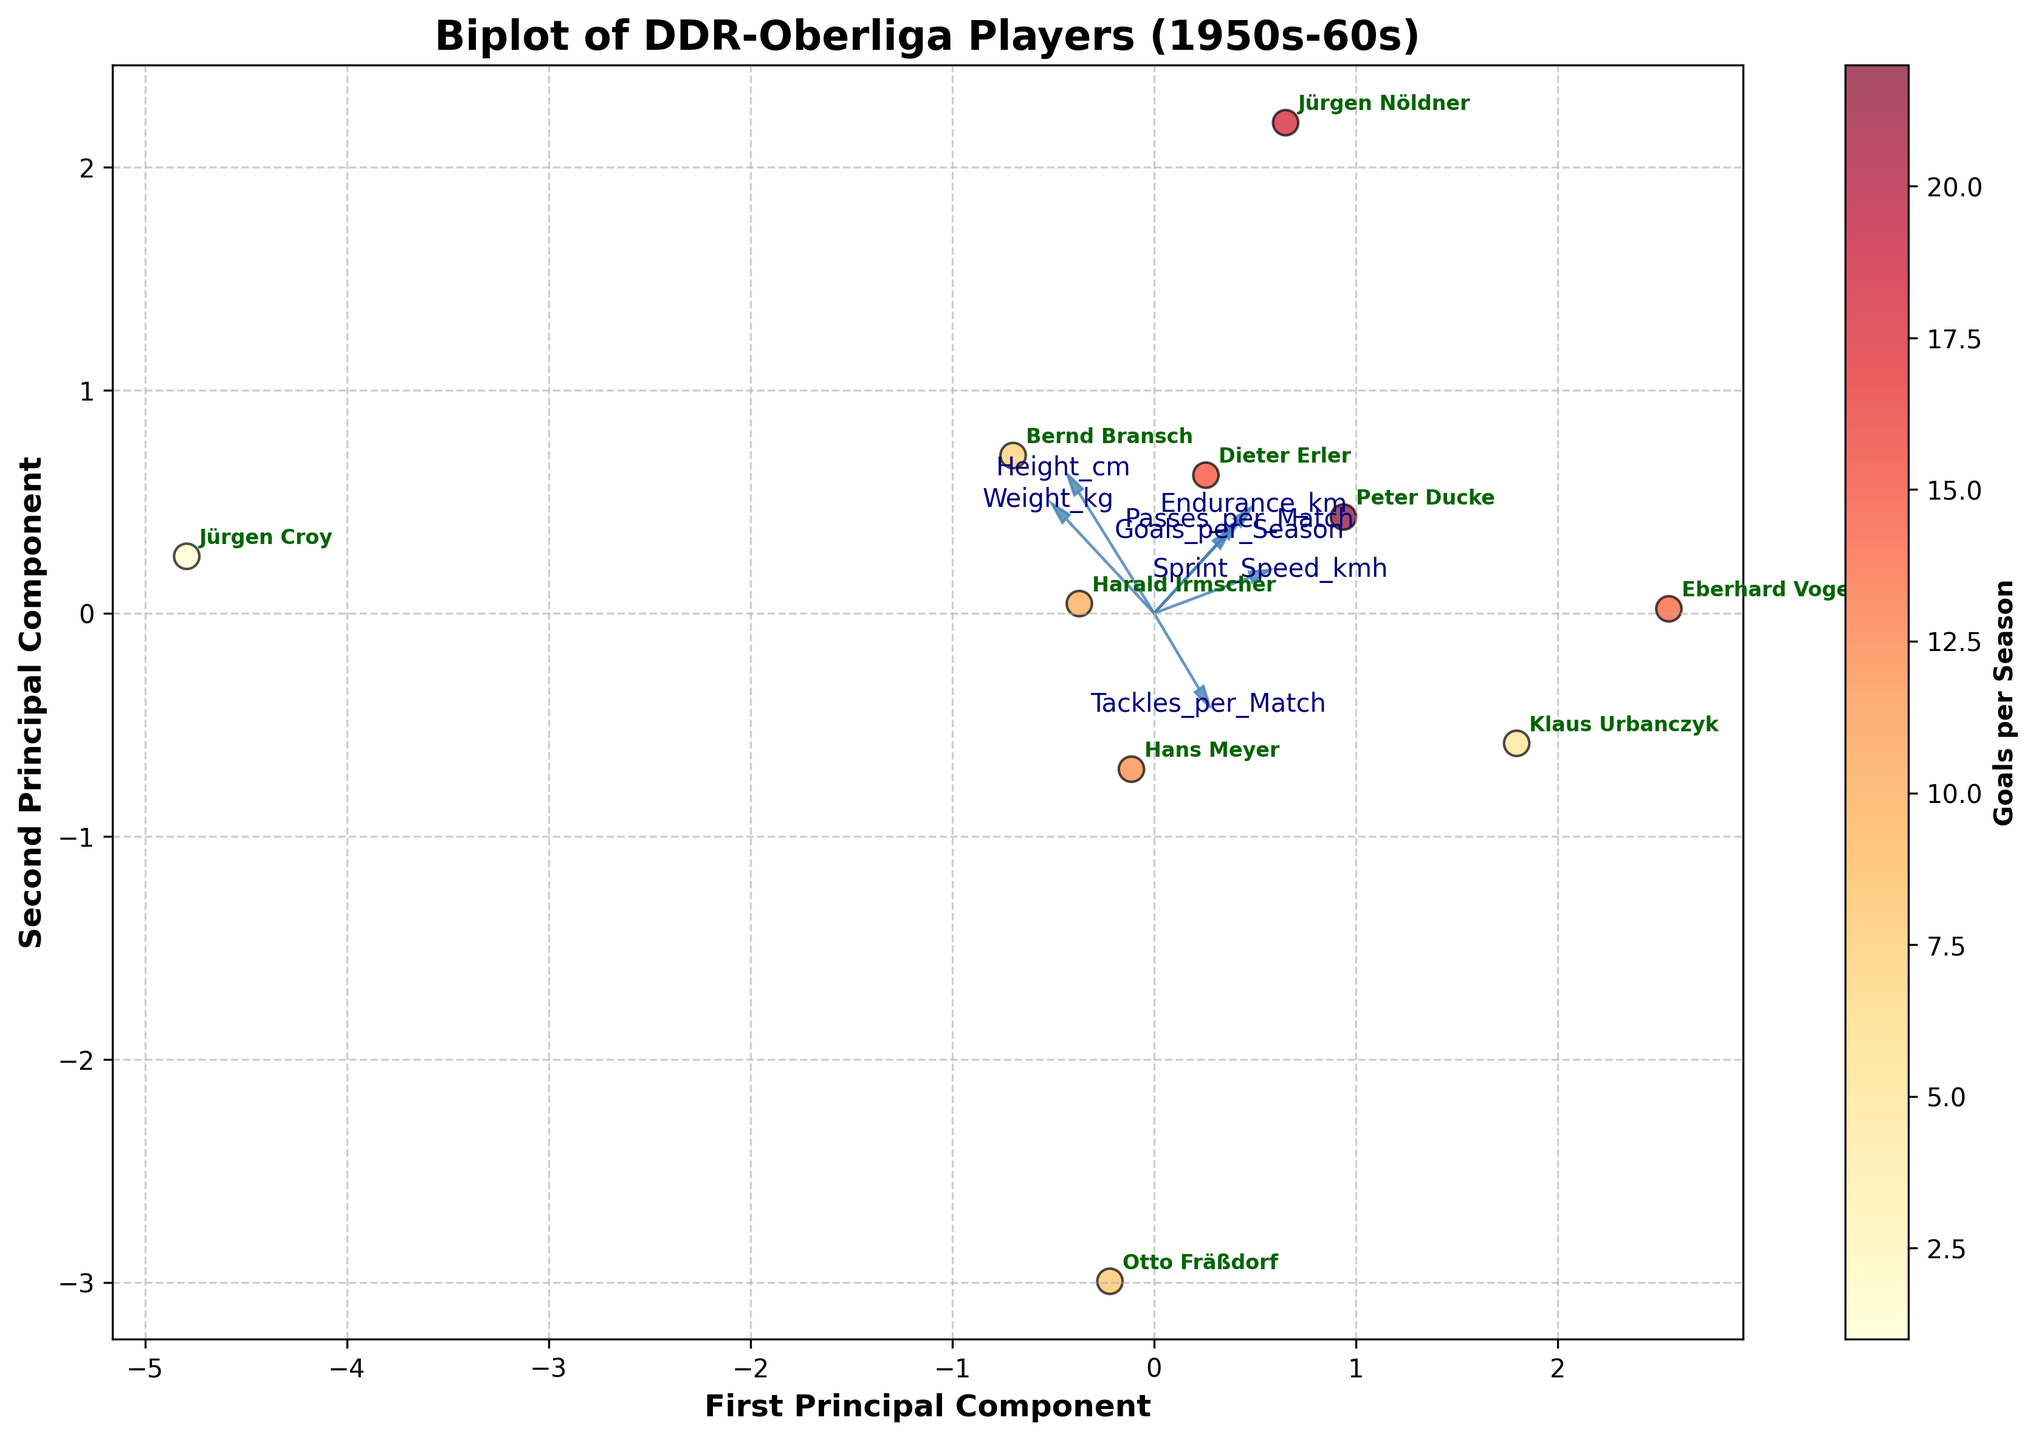How many players are represented in the biplot? The plot contains one dot per player. Count the number of dots to determine the number of players.
Answer: 10 What does the color of the dots represent on the biplot? The color of the dots represents the number of goals scored per season by each player, as indicated by the color bar labeled 'Goals per Season'.
Answer: Goals per Season Which player has the highest sprint speed and where is he located on the biplot? Locate the arrows for each feature; the highest sprint speed corresponds to the longest distance along the Sprint_Speed_kmh arrow. Find the dot in this direction and check its label.
Answer: Peter Ducke Which feature is most strongly associated with the first principal component? Identify which feature's arrow points most closely in the direction of the x-axis (first principal component). This determines the feature that contributes most to the first principal component.
Answer: Passes_per_Match What are the coordinates of Jürgen Nöldner in the biplot? Locate Jürgen Nöldner's name next to a point in the biplot and note down the x and y coordinates of that point.
Answer: Roughly (1.5, 0.8) Which player has the lowest score in the second principal component? Check the y-coordinates (second principal component) and identify the player with the lowest y-coordinate.
Answer: Jürgen Croy Which player has the highest number of tackles per match and where is he located on the biplot? The highest number of tackles per match will be furthest in the direction of the Tackles_per_Match arrow. Locate this point and check the player's label.
Answer: Bernd Bransch Are height and weight positively correlated according to the biplot? Examine the arrows for Height_cm and Weight_kg. If they point in similar directions, the features are positively correlated.
Answer: Yes Which player has both high endurance and a high number of passes per match? Look for players close to the direction of both the Endurance_km and Passes_per_Match arrows. Identify and cross-reference the player's location with the annotations.
Answer: Klaus Urbanczyk How are goals per season distributed among the players? Observe the color gradient of the points, which represents goals per season. Identify any color trends and the range of colors from the color bar.
Answer: Varies, with some players scoring low (darker) and some high (lighter) 